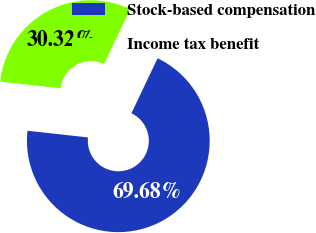Convert chart to OTSL. <chart><loc_0><loc_0><loc_500><loc_500><pie_chart><fcel>Stock-based compensation<fcel>Income tax benefit<nl><fcel>69.68%<fcel>30.32%<nl></chart> 